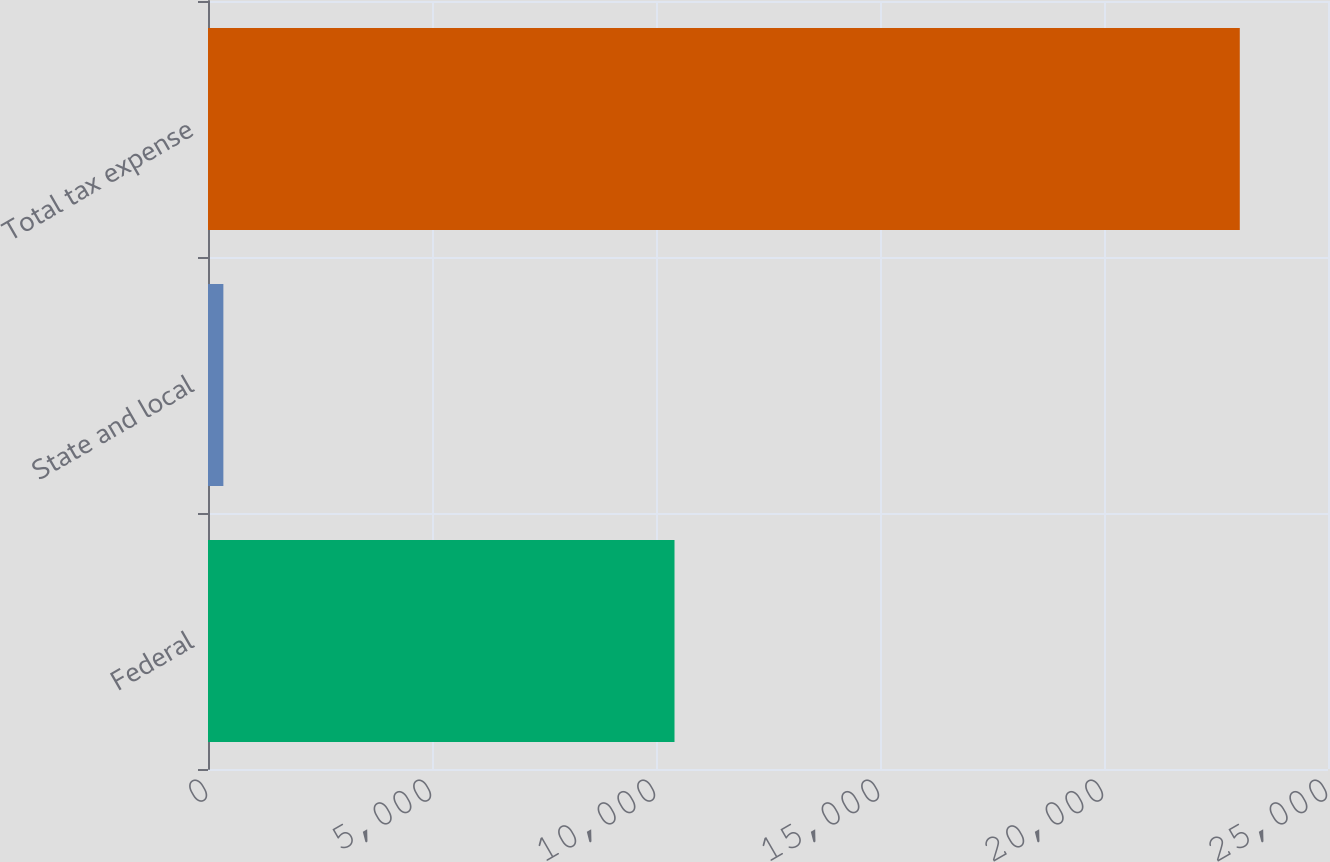<chart> <loc_0><loc_0><loc_500><loc_500><bar_chart><fcel>Federal<fcel>State and local<fcel>Total tax expense<nl><fcel>10413<fcel>343<fcel>23031<nl></chart> 